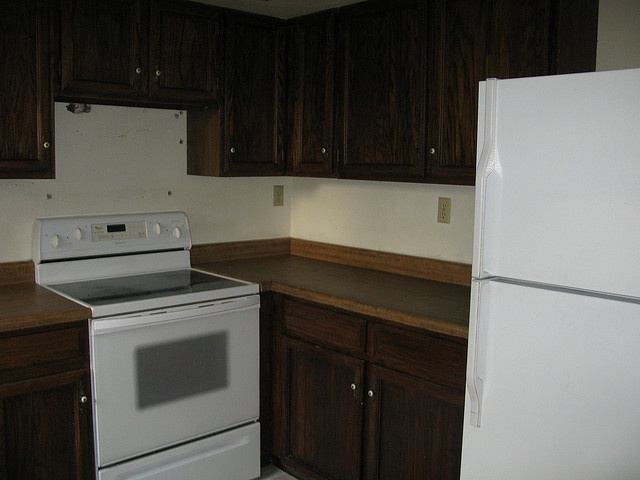Describe the objects in this image and their specific colors. I can see refrigerator in black, darkgray, and lightgray tones and oven in black and gray tones in this image. 